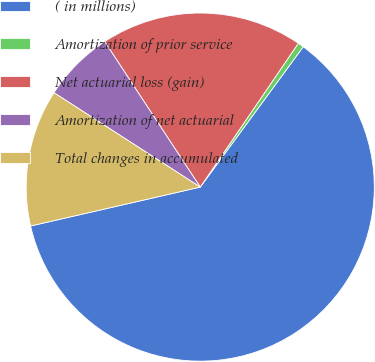Convert chart to OTSL. <chart><loc_0><loc_0><loc_500><loc_500><pie_chart><fcel>( in millions)<fcel>Amortization of prior service<fcel>Net actuarial loss (gain)<fcel>Amortization of net actuarial<fcel>Total changes in accumulated<nl><fcel>61.34%<fcel>0.55%<fcel>18.78%<fcel>6.63%<fcel>12.71%<nl></chart> 